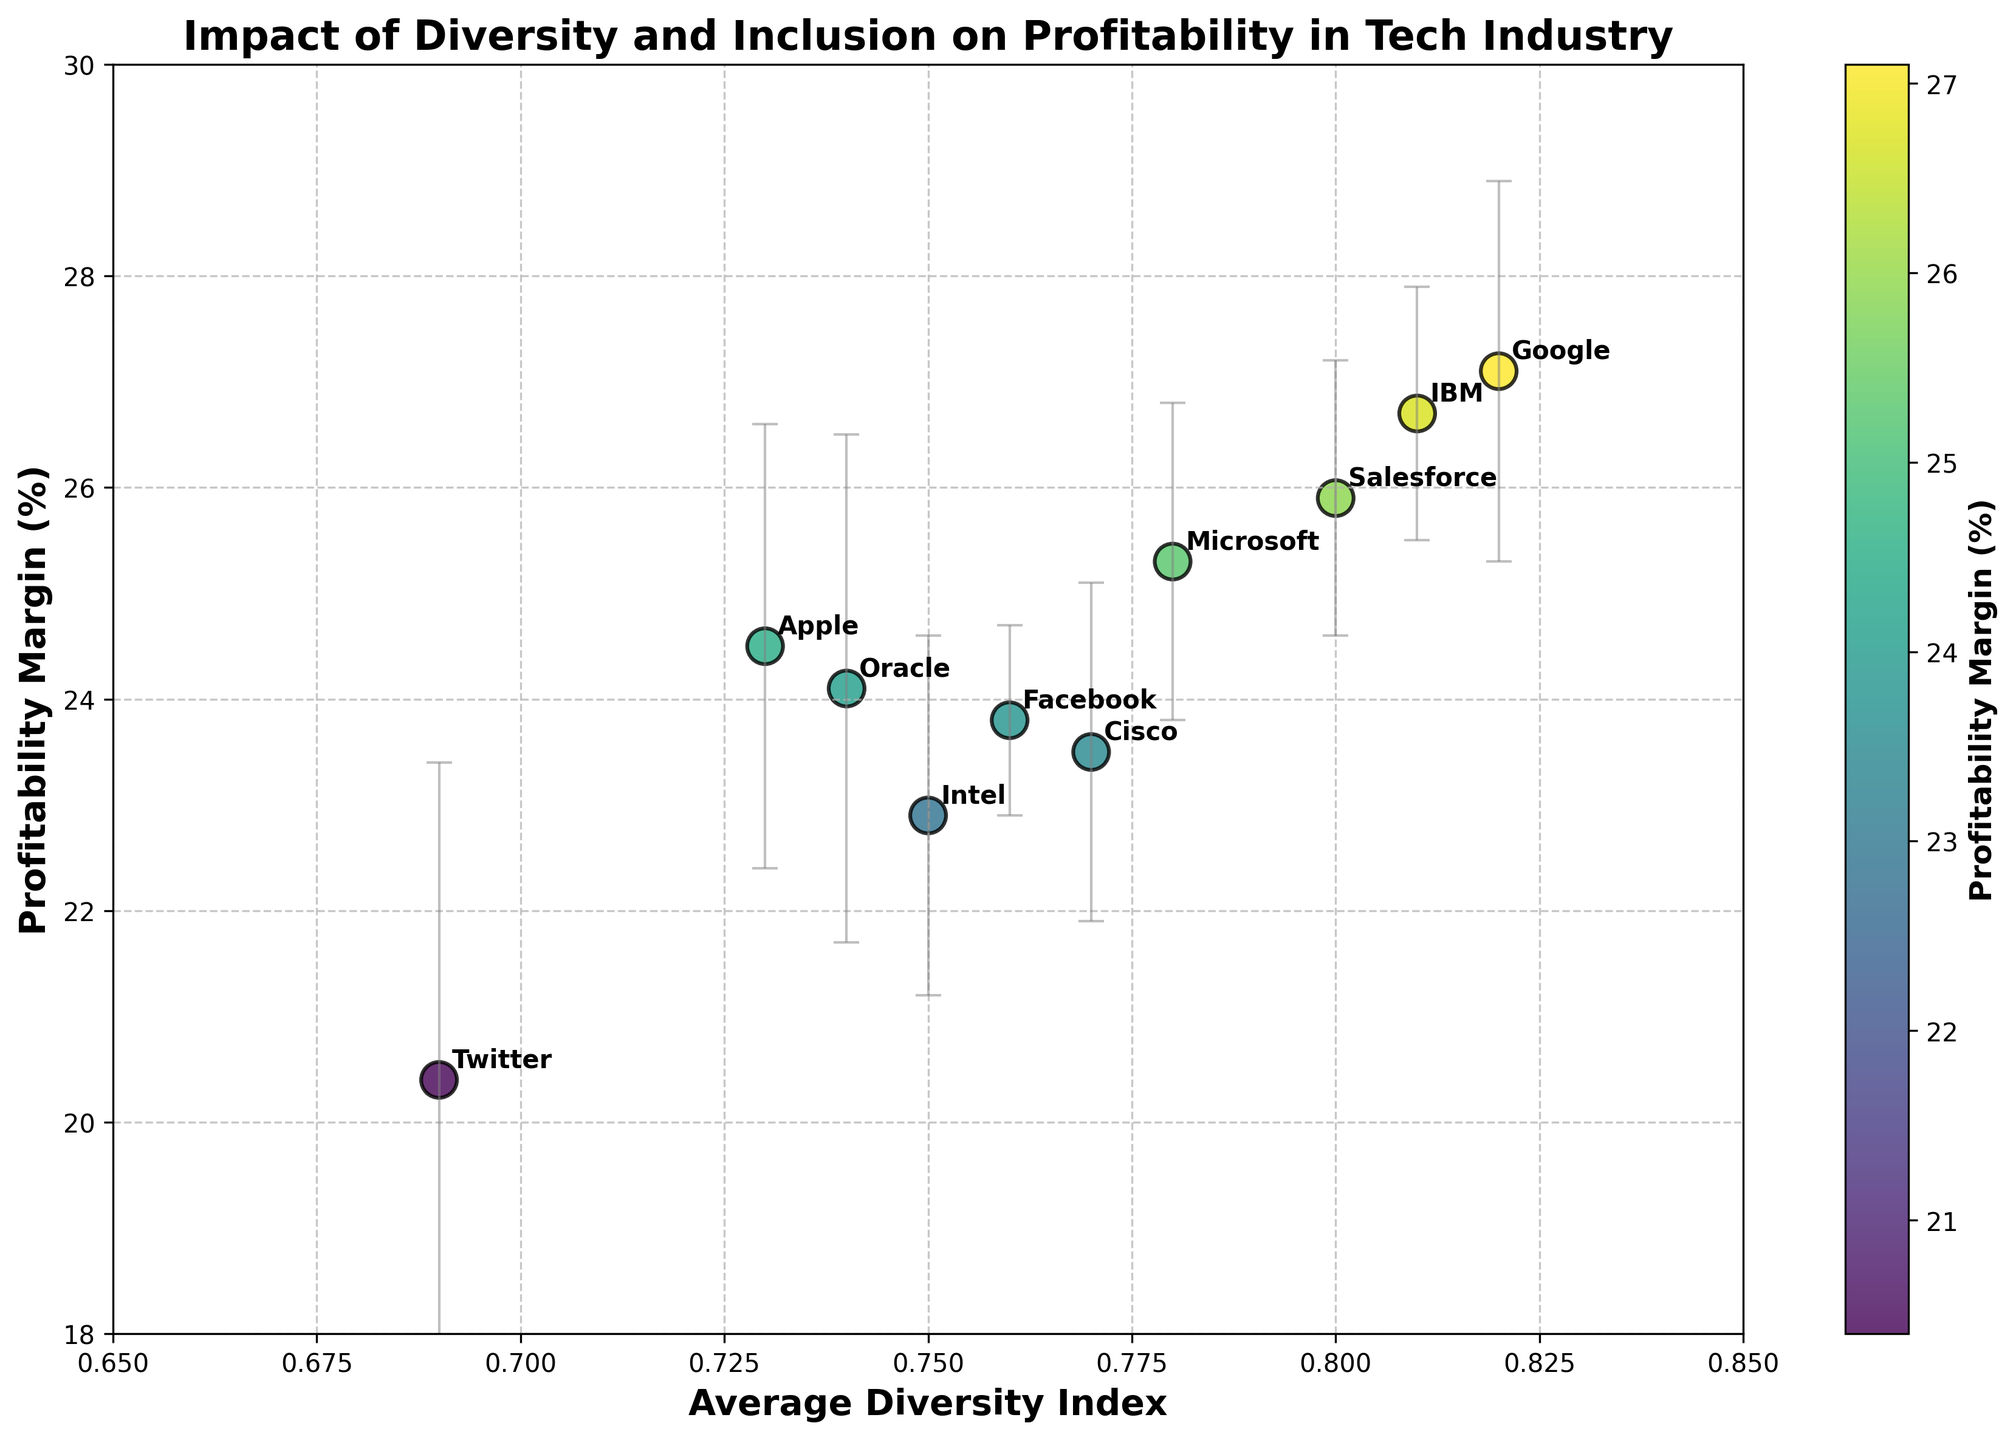What is the company with the highest Profitability Margin (%)? Look for the data point with the highest value on the y-axis labeled as Profitability Margin (%).
Answer: Google What is the title of the figure? The title is usually placed at the top of the plot and provides a summary of what the plot is displaying.
Answer: Impact of Diversity and Inclusion on Profitability in Tech Industry Which company has the lowest Average Diversity Index? Check the x-axis labeled as Average Diversity Index and find the data point that is furthest to the left.
Answer: Twitter What is the range of the y-axis? Look at the y-axis which is labeled as Profitability Margin (%) and provide the minimum and maximum values.
Answer: 18 to 30 What are the limits of the x-axis? Look at the x-axis which is labeled as Average Diversity Index and provide the minimum and maximum values.
Answer: 0.65 to 0.85 Among the companies plotted, which has the largest error bar for Profitability Margin (%)? Look for the data point with the longest error bar along the y-axis.
Answer: Twitter Which companies have a Profitability Margin (%) above 25%? Identify data points above the 25% mark on the y-axis.
Answer: Microsoft, Google, IBM, Salesforce What is the difference in Profitability Margin (%) between Apple and Facebook? Find the y-values for Apple (24.5%) and Facebook (23.8%) and calculate the difference.
Answer: 0.7% On average, do companies with higher Diversity Indexes tend to have higher Profitability Margins according to the plot? Observe the general trend or pattern of how the data points are spread relative to both axes.
Answer: Yes How is the Profitability Margin (%) related to the color of the data points? The color intensity corresponds to the Profitability Margin (%), with a color bar on the right indicating the range of values. Brighter colors generally indicate higher margins.
Answer: Higher margins are represented by brighter colors 